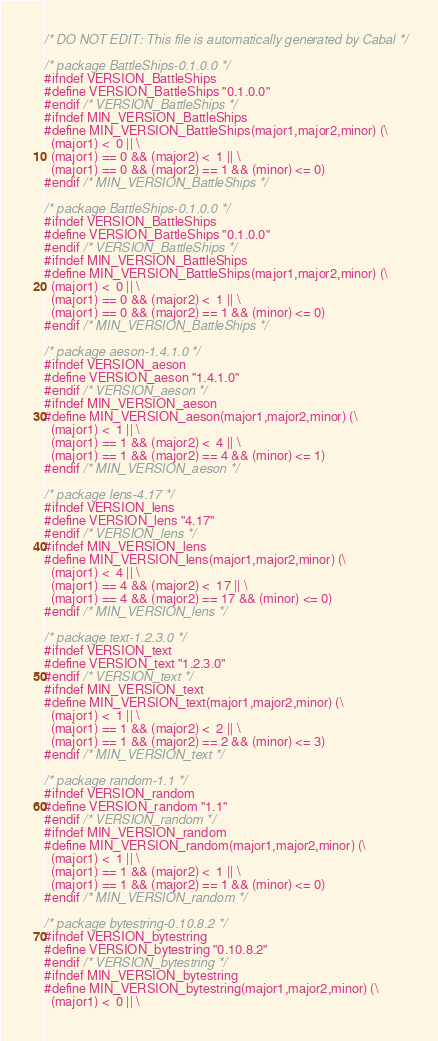Convert code to text. <code><loc_0><loc_0><loc_500><loc_500><_C_>/* DO NOT EDIT: This file is automatically generated by Cabal */

/* package BattleShips-0.1.0.0 */
#ifndef VERSION_BattleShips
#define VERSION_BattleShips "0.1.0.0"
#endif /* VERSION_BattleShips */
#ifndef MIN_VERSION_BattleShips
#define MIN_VERSION_BattleShips(major1,major2,minor) (\
  (major1) <  0 || \
  (major1) == 0 && (major2) <  1 || \
  (major1) == 0 && (major2) == 1 && (minor) <= 0)
#endif /* MIN_VERSION_BattleShips */

/* package BattleShips-0.1.0.0 */
#ifndef VERSION_BattleShips
#define VERSION_BattleShips "0.1.0.0"
#endif /* VERSION_BattleShips */
#ifndef MIN_VERSION_BattleShips
#define MIN_VERSION_BattleShips(major1,major2,minor) (\
  (major1) <  0 || \
  (major1) == 0 && (major2) <  1 || \
  (major1) == 0 && (major2) == 1 && (minor) <= 0)
#endif /* MIN_VERSION_BattleShips */

/* package aeson-1.4.1.0 */
#ifndef VERSION_aeson
#define VERSION_aeson "1.4.1.0"
#endif /* VERSION_aeson */
#ifndef MIN_VERSION_aeson
#define MIN_VERSION_aeson(major1,major2,minor) (\
  (major1) <  1 || \
  (major1) == 1 && (major2) <  4 || \
  (major1) == 1 && (major2) == 4 && (minor) <= 1)
#endif /* MIN_VERSION_aeson */

/* package lens-4.17 */
#ifndef VERSION_lens
#define VERSION_lens "4.17"
#endif /* VERSION_lens */
#ifndef MIN_VERSION_lens
#define MIN_VERSION_lens(major1,major2,minor) (\
  (major1) <  4 || \
  (major1) == 4 && (major2) <  17 || \
  (major1) == 4 && (major2) == 17 && (minor) <= 0)
#endif /* MIN_VERSION_lens */

/* package text-1.2.3.0 */
#ifndef VERSION_text
#define VERSION_text "1.2.3.0"
#endif /* VERSION_text */
#ifndef MIN_VERSION_text
#define MIN_VERSION_text(major1,major2,minor) (\
  (major1) <  1 || \
  (major1) == 1 && (major2) <  2 || \
  (major1) == 1 && (major2) == 2 && (minor) <= 3)
#endif /* MIN_VERSION_text */

/* package random-1.1 */
#ifndef VERSION_random
#define VERSION_random "1.1"
#endif /* VERSION_random */
#ifndef MIN_VERSION_random
#define MIN_VERSION_random(major1,major2,minor) (\
  (major1) <  1 || \
  (major1) == 1 && (major2) <  1 || \
  (major1) == 1 && (major2) == 1 && (minor) <= 0)
#endif /* MIN_VERSION_random */

/* package bytestring-0.10.8.2 */
#ifndef VERSION_bytestring
#define VERSION_bytestring "0.10.8.2"
#endif /* VERSION_bytestring */
#ifndef MIN_VERSION_bytestring
#define MIN_VERSION_bytestring(major1,major2,minor) (\
  (major1) <  0 || \</code> 